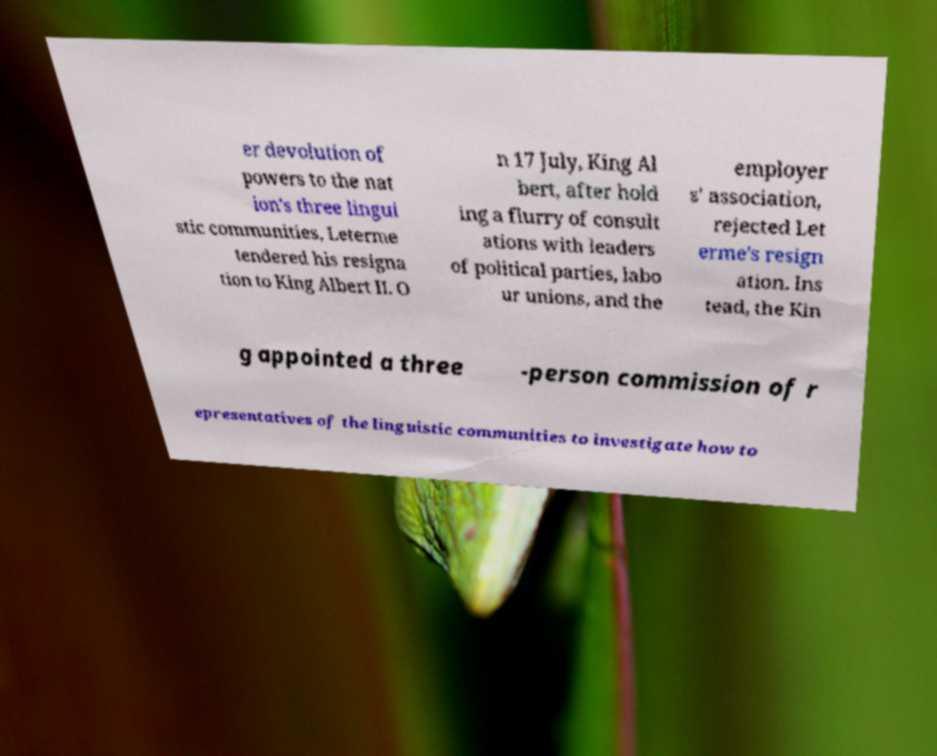Please identify and transcribe the text found in this image. er devolution of powers to the nat ion's three lingui stic communities, Leterme tendered his resigna tion to King Albert II. O n 17 July, King Al bert, after hold ing a flurry of consult ations with leaders of political parties, labo ur unions, and the employer s' association, rejected Let erme's resign ation. Ins tead, the Kin g appointed a three -person commission of r epresentatives of the linguistic communities to investigate how to 